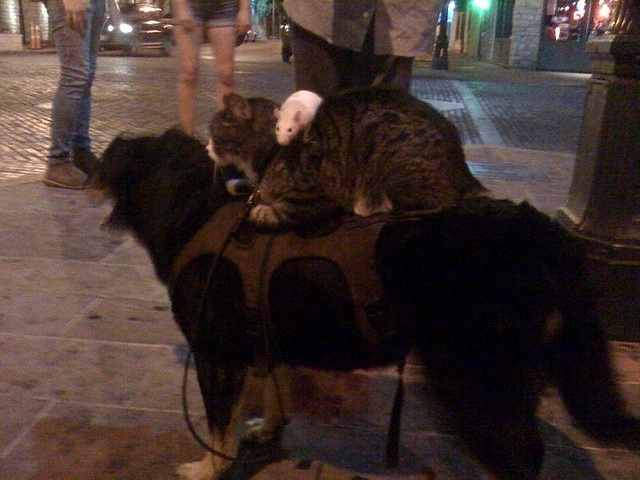Describe the objects in this image and their specific colors. I can see dog in gray, black, and maroon tones, cat in gray, black, maroon, and brown tones, people in gray, black, and brown tones, people in gray, black, and maroon tones, and people in gray, brown, and maroon tones in this image. 